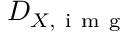Convert formula to latex. <formula><loc_0><loc_0><loc_500><loc_500>D _ { X , i m g }</formula> 